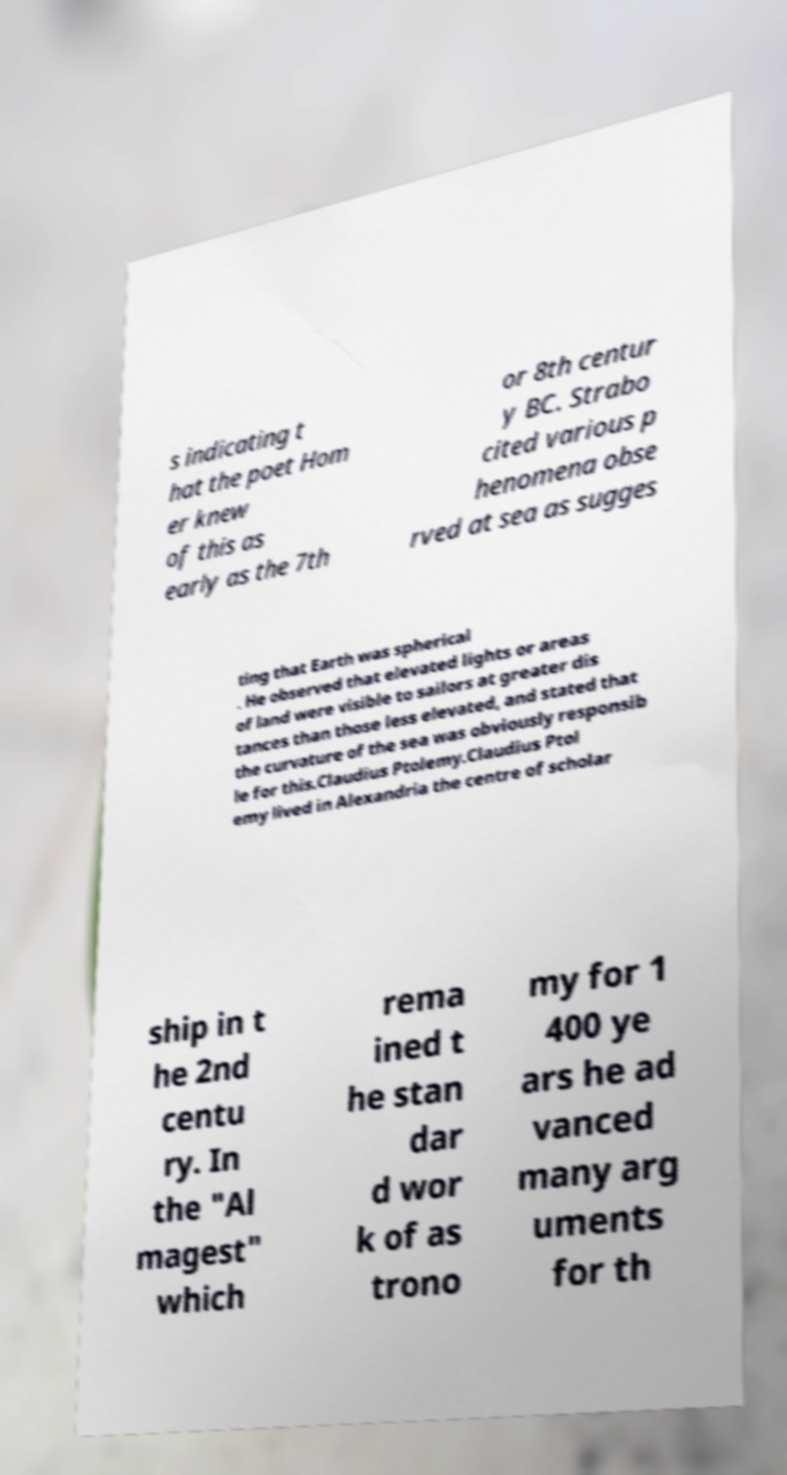Please identify and transcribe the text found in this image. s indicating t hat the poet Hom er knew of this as early as the 7th or 8th centur y BC. Strabo cited various p henomena obse rved at sea as sugges ting that Earth was spherical . He observed that elevated lights or areas of land were visible to sailors at greater dis tances than those less elevated, and stated that the curvature of the sea was obviously responsib le for this.Claudius Ptolemy.Claudius Ptol emy lived in Alexandria the centre of scholar ship in t he 2nd centu ry. In the "Al magest" which rema ined t he stan dar d wor k of as trono my for 1 400 ye ars he ad vanced many arg uments for th 